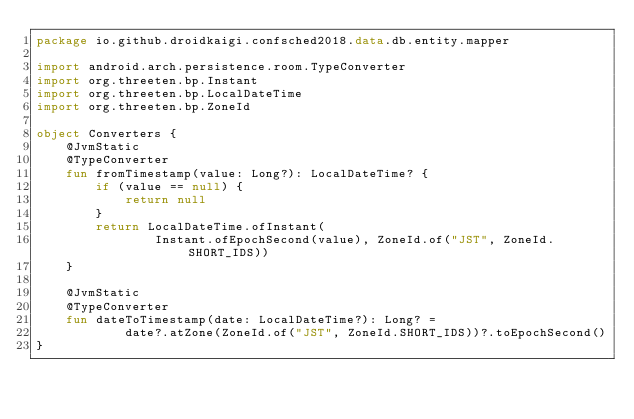Convert code to text. <code><loc_0><loc_0><loc_500><loc_500><_Kotlin_>package io.github.droidkaigi.confsched2018.data.db.entity.mapper

import android.arch.persistence.room.TypeConverter
import org.threeten.bp.Instant
import org.threeten.bp.LocalDateTime
import org.threeten.bp.ZoneId

object Converters {
    @JvmStatic
    @TypeConverter
    fun fromTimestamp(value: Long?): LocalDateTime? {
        if (value == null) {
            return null
        }
        return LocalDateTime.ofInstant(
                Instant.ofEpochSecond(value), ZoneId.of("JST", ZoneId.SHORT_IDS))
    }

    @JvmStatic
    @TypeConverter
    fun dateToTimestamp(date: LocalDateTime?): Long? =
            date?.atZone(ZoneId.of("JST", ZoneId.SHORT_IDS))?.toEpochSecond()
}
</code> 